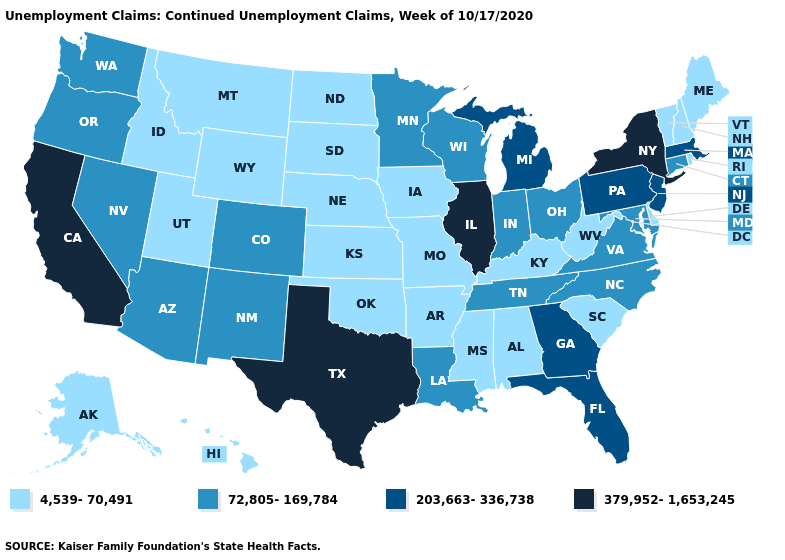What is the highest value in states that border Utah?
Concise answer only. 72,805-169,784. Name the states that have a value in the range 4,539-70,491?
Keep it brief. Alabama, Alaska, Arkansas, Delaware, Hawaii, Idaho, Iowa, Kansas, Kentucky, Maine, Mississippi, Missouri, Montana, Nebraska, New Hampshire, North Dakota, Oklahoma, Rhode Island, South Carolina, South Dakota, Utah, Vermont, West Virginia, Wyoming. Name the states that have a value in the range 203,663-336,738?
Give a very brief answer. Florida, Georgia, Massachusetts, Michigan, New Jersey, Pennsylvania. What is the lowest value in the USA?
Give a very brief answer. 4,539-70,491. Among the states that border Pennsylvania , which have the lowest value?
Write a very short answer. Delaware, West Virginia. Among the states that border North Dakota , does Montana have the lowest value?
Quick response, please. Yes. What is the value of Iowa?
Quick response, please. 4,539-70,491. What is the value of Alabama?
Be succinct. 4,539-70,491. What is the value of Indiana?
Be succinct. 72,805-169,784. What is the value of New York?
Be succinct. 379,952-1,653,245. Name the states that have a value in the range 379,952-1,653,245?
Write a very short answer. California, Illinois, New York, Texas. Name the states that have a value in the range 203,663-336,738?
Keep it brief. Florida, Georgia, Massachusetts, Michigan, New Jersey, Pennsylvania. Which states have the lowest value in the MidWest?
Answer briefly. Iowa, Kansas, Missouri, Nebraska, North Dakota, South Dakota. Name the states that have a value in the range 203,663-336,738?
Short answer required. Florida, Georgia, Massachusetts, Michigan, New Jersey, Pennsylvania. Which states have the highest value in the USA?
Concise answer only. California, Illinois, New York, Texas. 